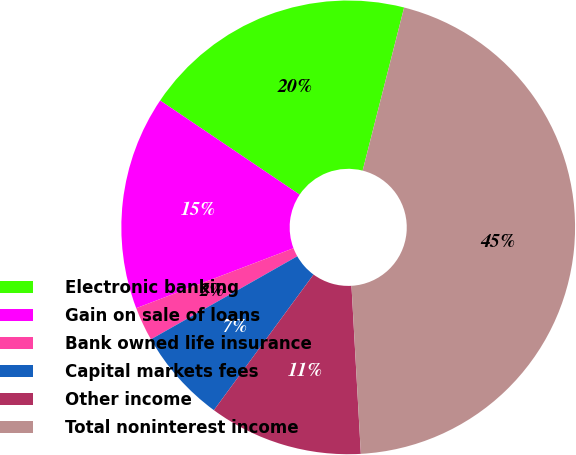Convert chart to OTSL. <chart><loc_0><loc_0><loc_500><loc_500><pie_chart><fcel>Electronic banking<fcel>Gain on sale of loans<fcel>Bank owned life insurance<fcel>Capital markets fees<fcel>Other income<fcel>Total noninterest income<nl><fcel>19.52%<fcel>15.24%<fcel>2.42%<fcel>6.7%<fcel>10.97%<fcel>45.15%<nl></chart> 